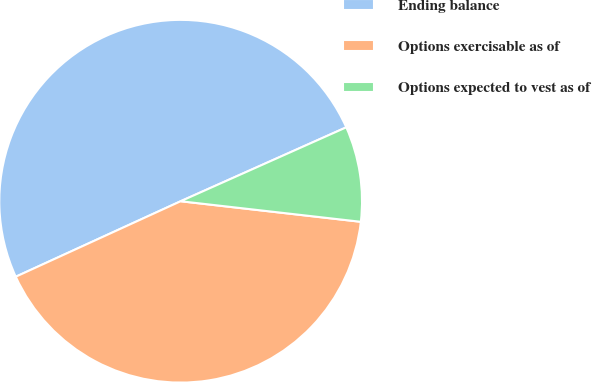<chart> <loc_0><loc_0><loc_500><loc_500><pie_chart><fcel>Ending balance<fcel>Options exercisable as of<fcel>Options expected to vest as of<nl><fcel>50.15%<fcel>41.36%<fcel>8.49%<nl></chart> 